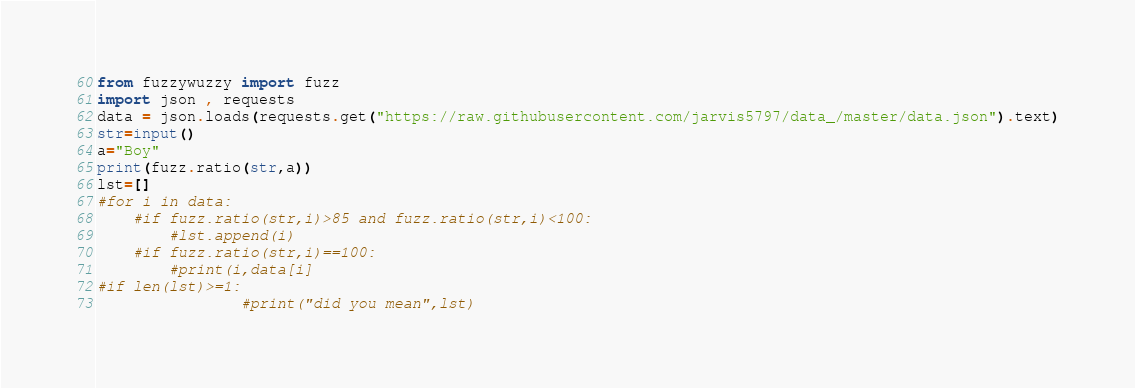Convert code to text. <code><loc_0><loc_0><loc_500><loc_500><_Python_>from fuzzywuzzy import fuzz
import json , requests
data = json.loads(requests.get("https://raw.githubusercontent.com/jarvis5797/data_/master/data.json").text)
str=input()
a="Boy"
print(fuzz.ratio(str,a))
lst=[]
#for i in data:	
	#if fuzz.ratio(str,i)>85 and fuzz.ratio(str,i)<100:
		#lst.append(i)
	#if fuzz.ratio(str,i)==100:
		#print(i,data[i]
#if len(lst)>=1:
                #print("did you mean",lst)
</code> 